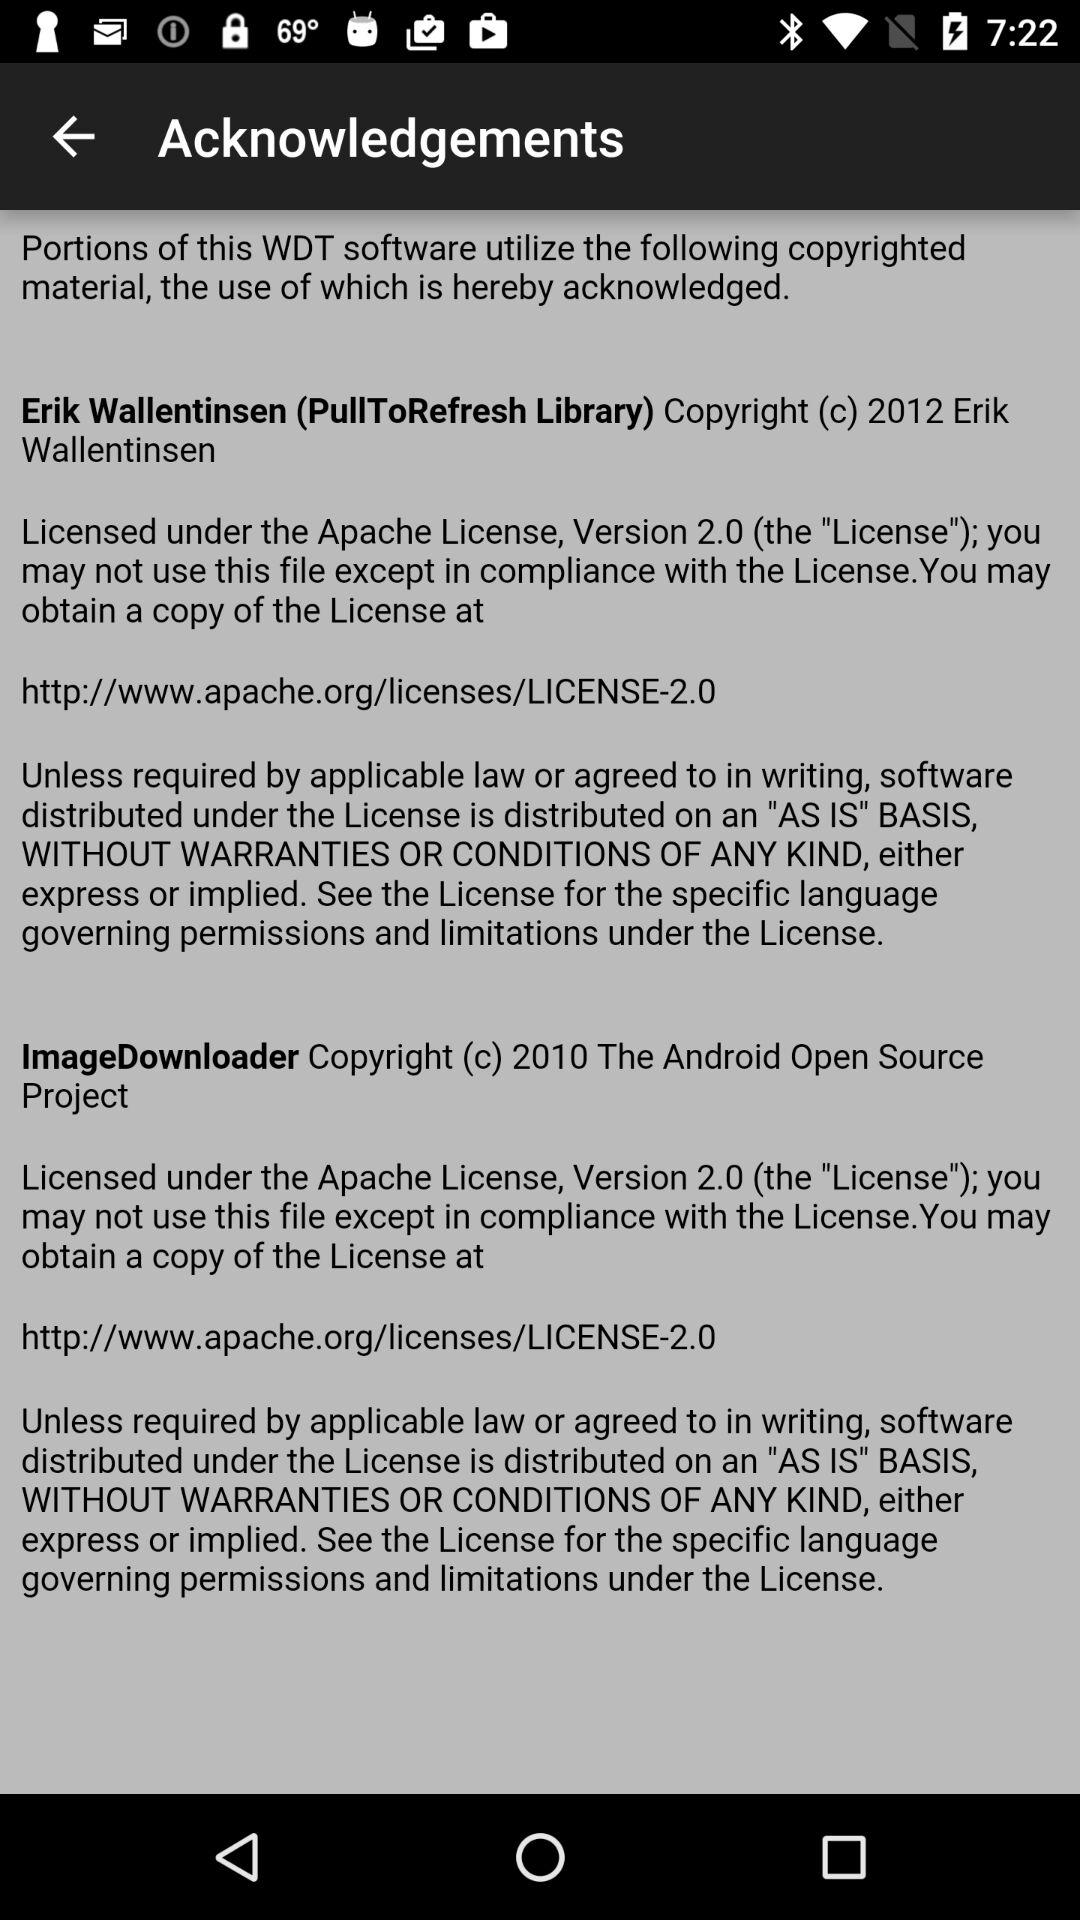How many different copyright holders are acknowledged on the screen?
Answer the question using a single word or phrase. 2 